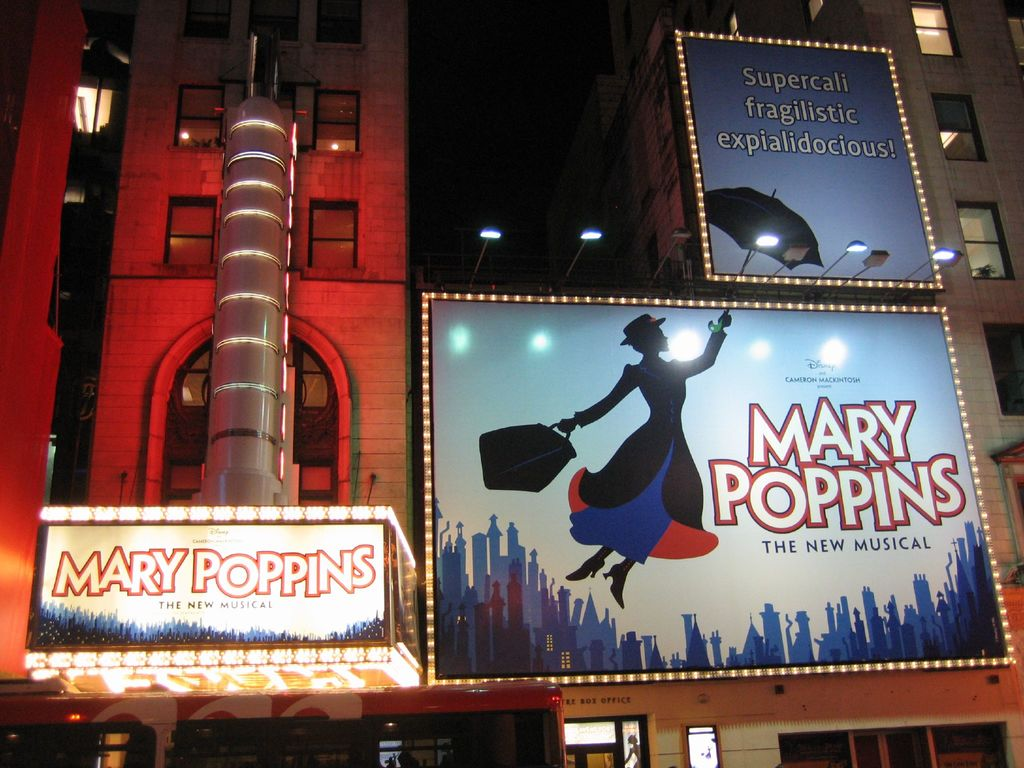What might the atmosphere inside the theater be like during a show? Inside the theater, one would likely encounter an atmosphere teeming with excitement and anticipation. As 'Mary Poppins' is known for its magical and heartwarming narrative, the interior ambiance would reflect this with ornate decorations and a lively buzz among the audience. The musical's immersive experience, bolstered by enchanting soundtracks and exquisite performances, would envelop the audience in a world of creativity and delight. The joyous reactions and interactions amongst the attendees would amplify the vibrant and engaging environment. 